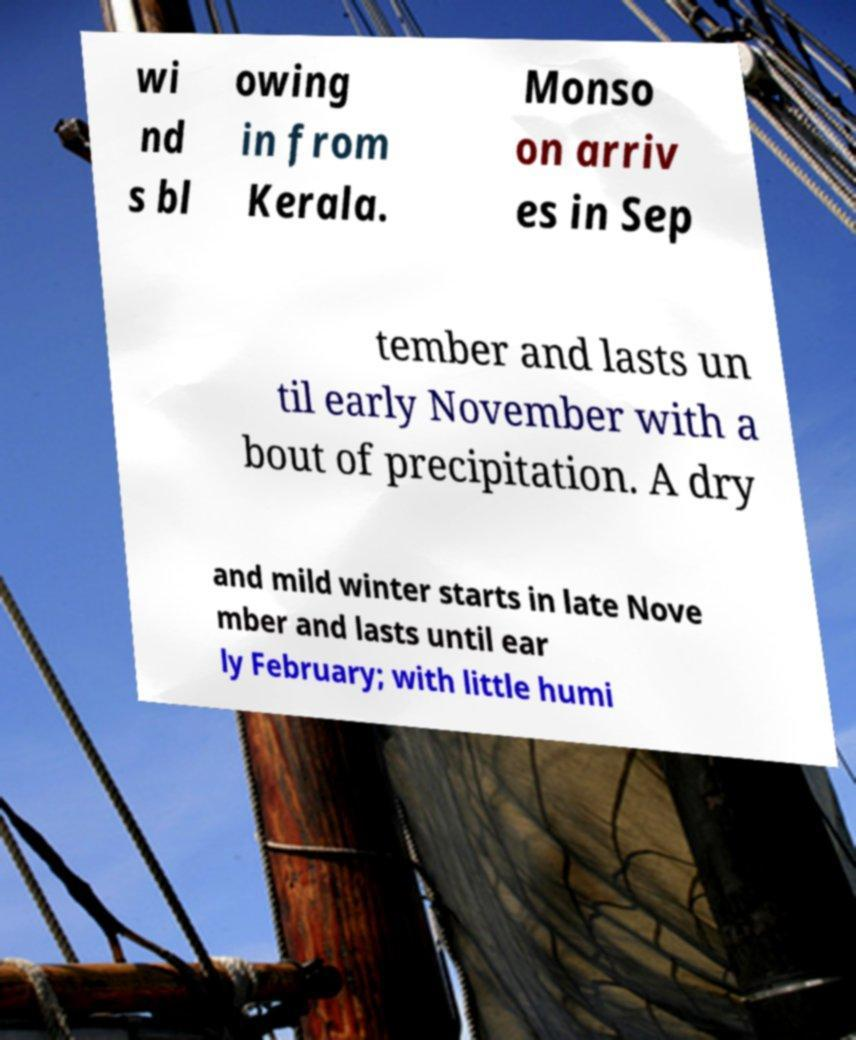I need the written content from this picture converted into text. Can you do that? wi nd s bl owing in from Kerala. Monso on arriv es in Sep tember and lasts un til early November with a bout of precipitation. A dry and mild winter starts in late Nove mber and lasts until ear ly February; with little humi 